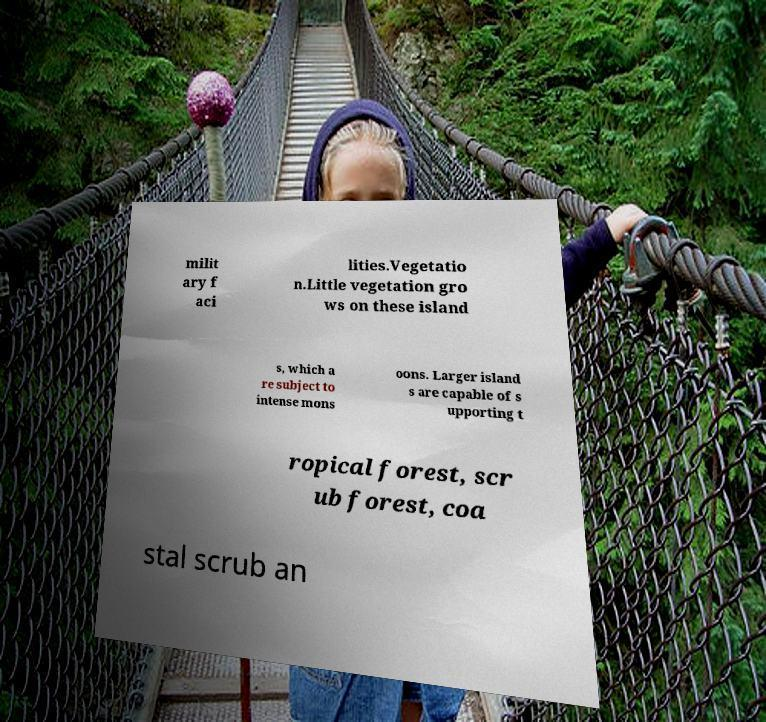Can you read and provide the text displayed in the image?This photo seems to have some interesting text. Can you extract and type it out for me? milit ary f aci lities.Vegetatio n.Little vegetation gro ws on these island s, which a re subject to intense mons oons. Larger island s are capable of s upporting t ropical forest, scr ub forest, coa stal scrub an 